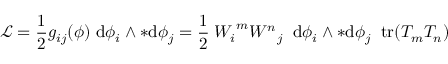Convert formula to latex. <formula><loc_0><loc_0><loc_500><loc_500>{ \mathcal { L } } = { \frac { 1 } { 2 } } g _ { i j } ( \phi ) \, d \phi _ { i } \wedge { * d \phi _ { j } } = { \frac { 1 } { 2 } } \, { W _ { i } } ^ { m } { W ^ { n } } _ { j } \, d \phi _ { i } \wedge { * d \phi _ { j } } \, t r ( T _ { m } T _ { n } )</formula> 